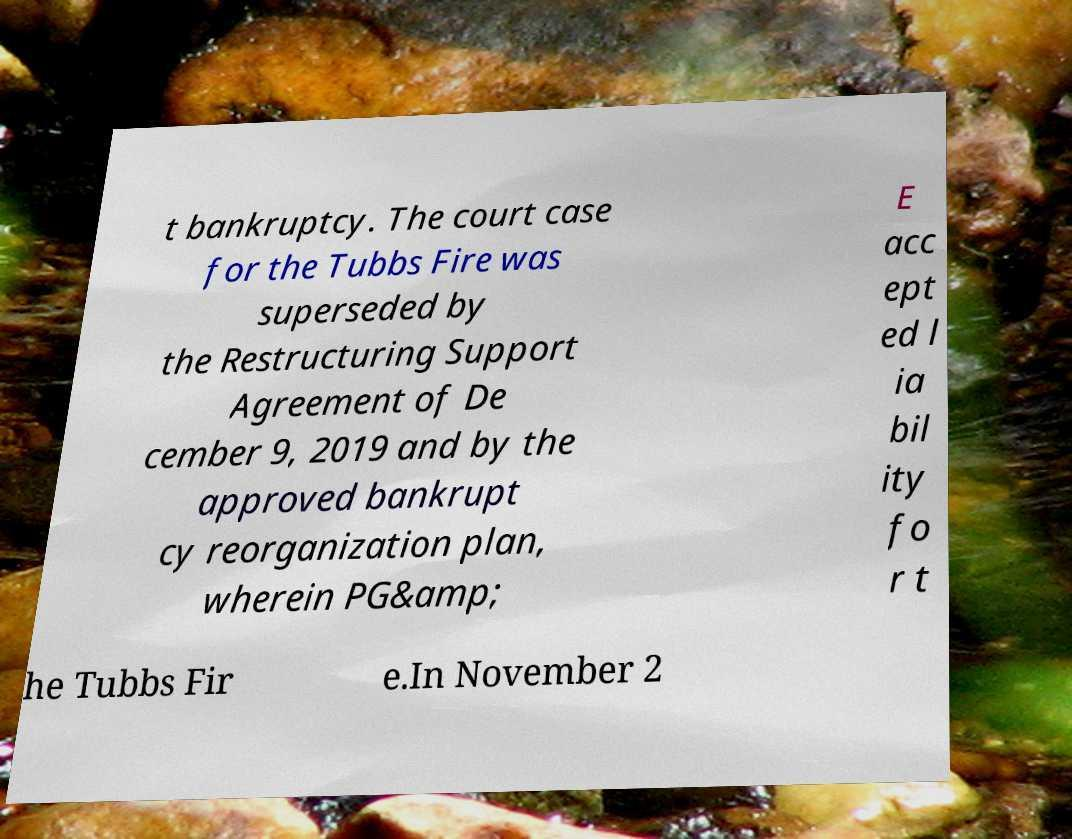What messages or text are displayed in this image? I need them in a readable, typed format. t bankruptcy. The court case for the Tubbs Fire was superseded by the Restructuring Support Agreement of De cember 9, 2019 and by the approved bankrupt cy reorganization plan, wherein PG&amp; E acc ept ed l ia bil ity fo r t he Tubbs Fir e.In November 2 